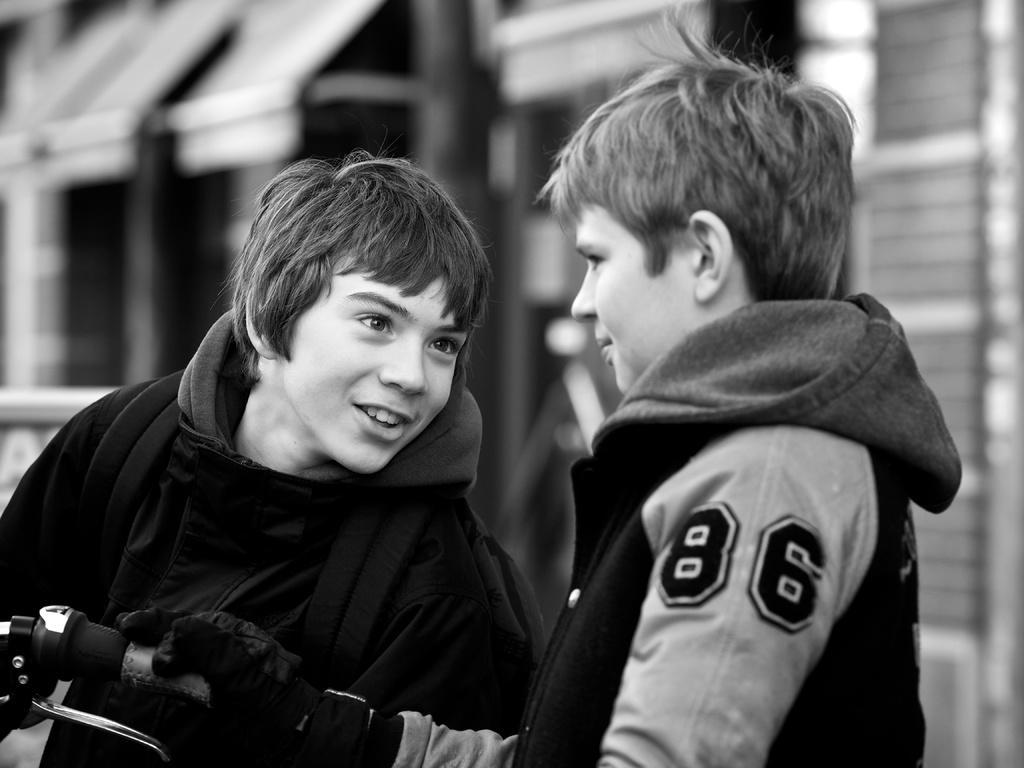In one or two sentences, can you explain what this image depicts? In this image, we can see two kids standing, they are wearing jackets, we can see the handle of a bicycle, there is a blur background. 